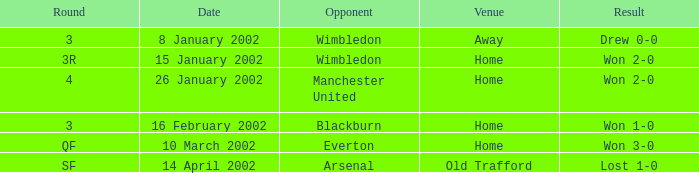What is the Opponent with a Round with 3, and a Venue of home? Blackburn. 